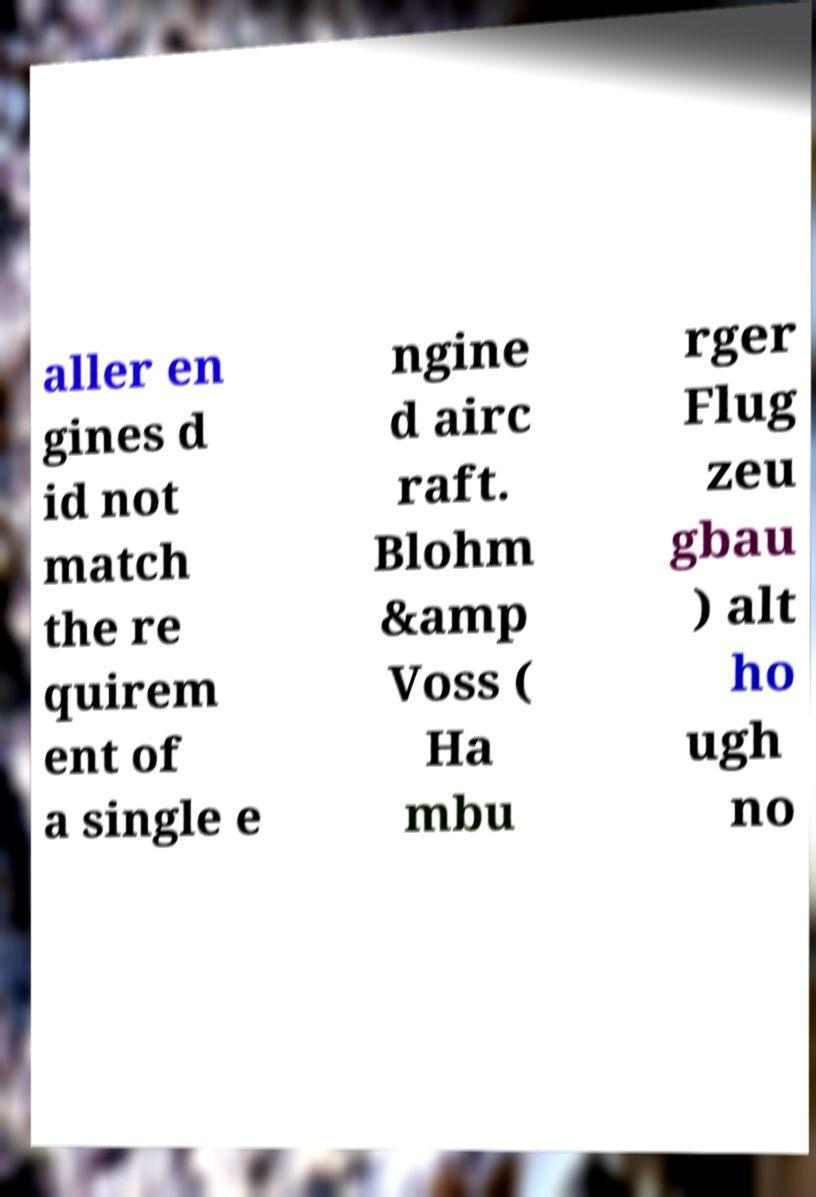I need the written content from this picture converted into text. Can you do that? aller en gines d id not match the re quirem ent of a single e ngine d airc raft. Blohm &amp Voss ( Ha mbu rger Flug zeu gbau ) alt ho ugh no 